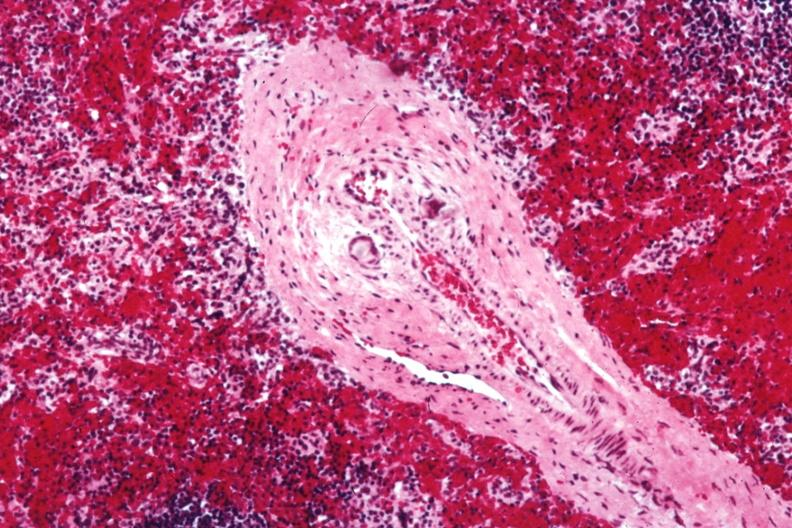s giant cells in wall containing crystalline material postoperative cardiac surgery thought to be silicon?
Answer the question using a single word or phrase. Yes 